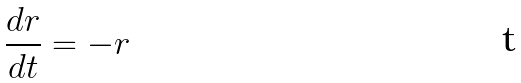<formula> <loc_0><loc_0><loc_500><loc_500>\frac { d r } { d t } = - r</formula> 